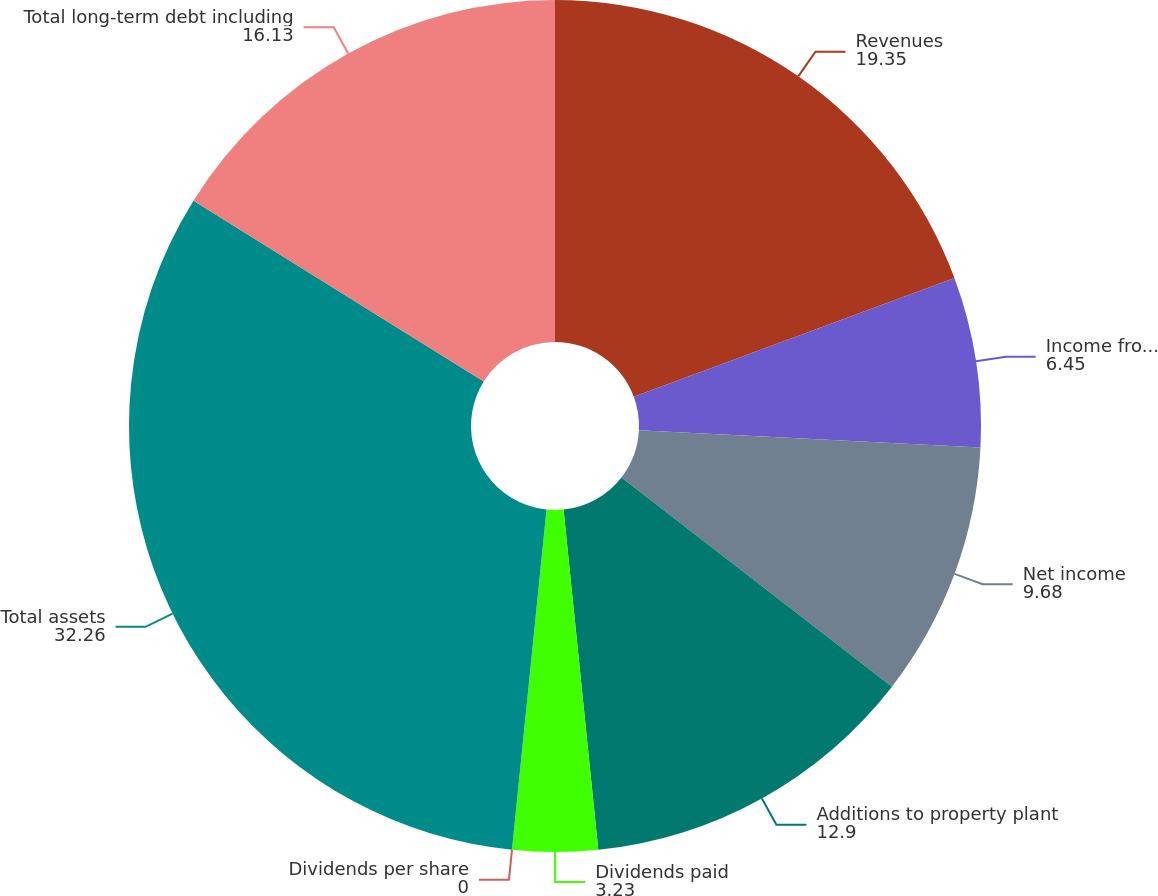<chart> <loc_0><loc_0><loc_500><loc_500><pie_chart><fcel>Revenues<fcel>Income from continuing<fcel>Net income<fcel>Additions to property plant<fcel>Dividends paid<fcel>Dividends per share<fcel>Total assets<fcel>Total long-term debt including<nl><fcel>19.35%<fcel>6.45%<fcel>9.68%<fcel>12.9%<fcel>3.23%<fcel>0.0%<fcel>32.26%<fcel>16.13%<nl></chart> 